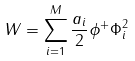Convert formula to latex. <formula><loc_0><loc_0><loc_500><loc_500>W = \sum _ { i = 1 } ^ { M } \frac { a _ { i } } { 2 } \phi ^ { + } \Phi _ { i } ^ { 2 }</formula> 